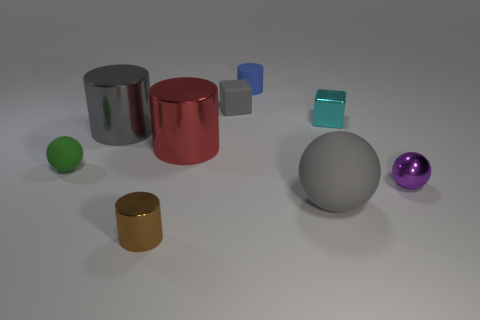There is a big shiny object left of the tiny brown cylinder; how many red shiny cylinders are behind it?
Your response must be concise. 0. Is the shape of the small purple object the same as the large red shiny object?
Your answer should be compact. No. Is there any other thing that has the same color as the big rubber object?
Your response must be concise. Yes. There is a cyan metal thing; does it have the same shape as the gray matte thing left of the blue rubber cylinder?
Offer a terse response. Yes. There is a large cylinder on the left side of the small cylinder that is in front of the large cylinder to the left of the big red shiny cylinder; what color is it?
Offer a very short reply. Gray. Is there any other thing that has the same material as the gray block?
Provide a short and direct response. Yes. Do the large gray thing that is left of the rubber cylinder and the big red shiny thing have the same shape?
Offer a terse response. Yes. What material is the brown object?
Make the answer very short. Metal. The small rubber thing that is left of the big gray thing that is behind the tiny ball on the right side of the brown metal thing is what shape?
Keep it short and to the point. Sphere. How many other objects are the same shape as the tiny green object?
Keep it short and to the point. 2. 